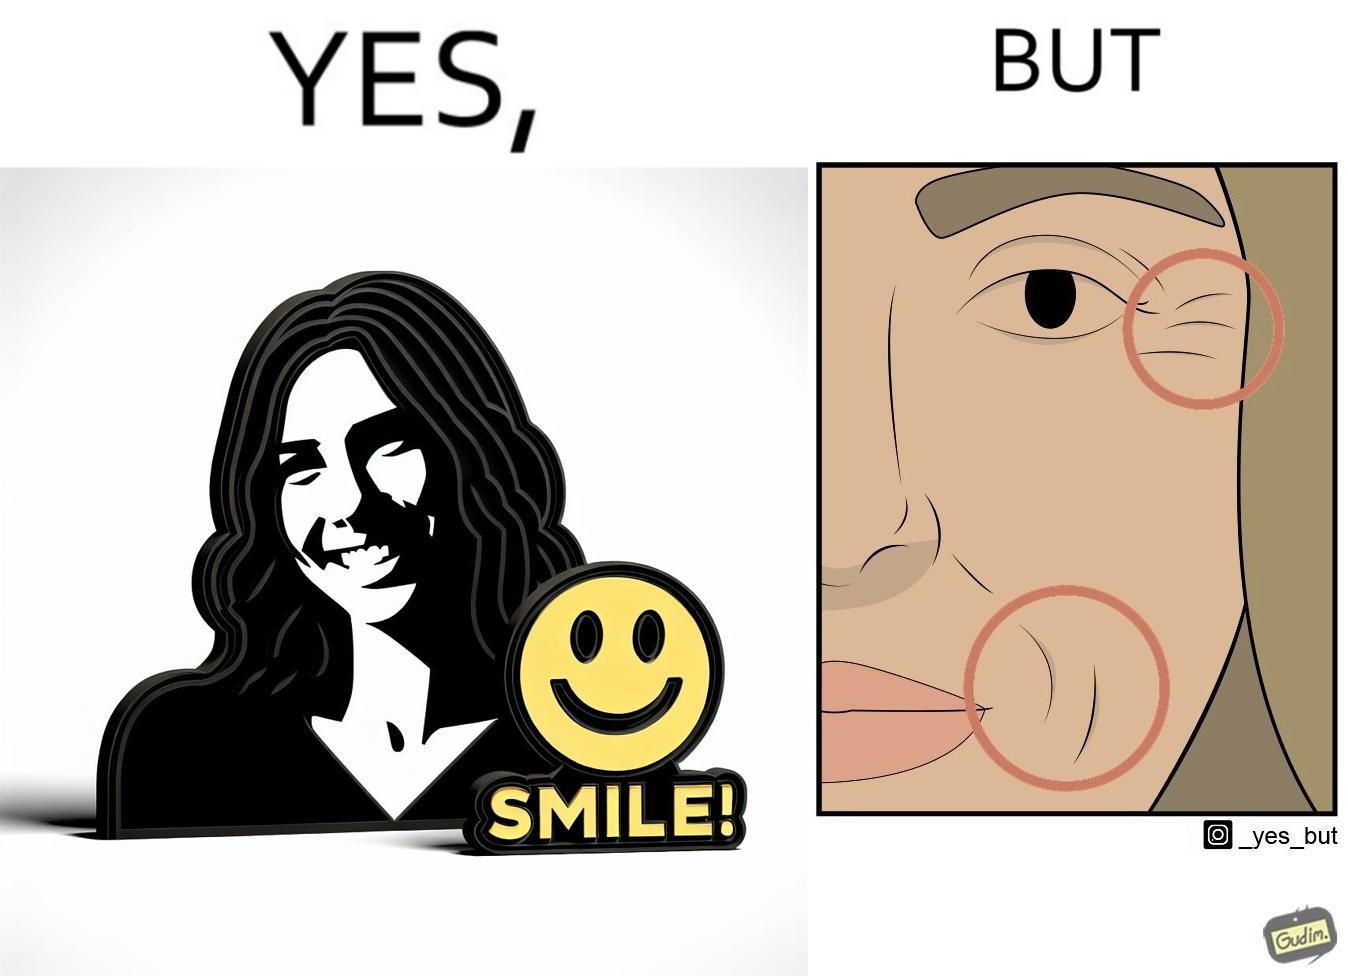Describe the satirical element in this image. The image is ironical because while it suggests people to smile it also shows the wrinkles that can be caused around lips and eyes because of smiling 